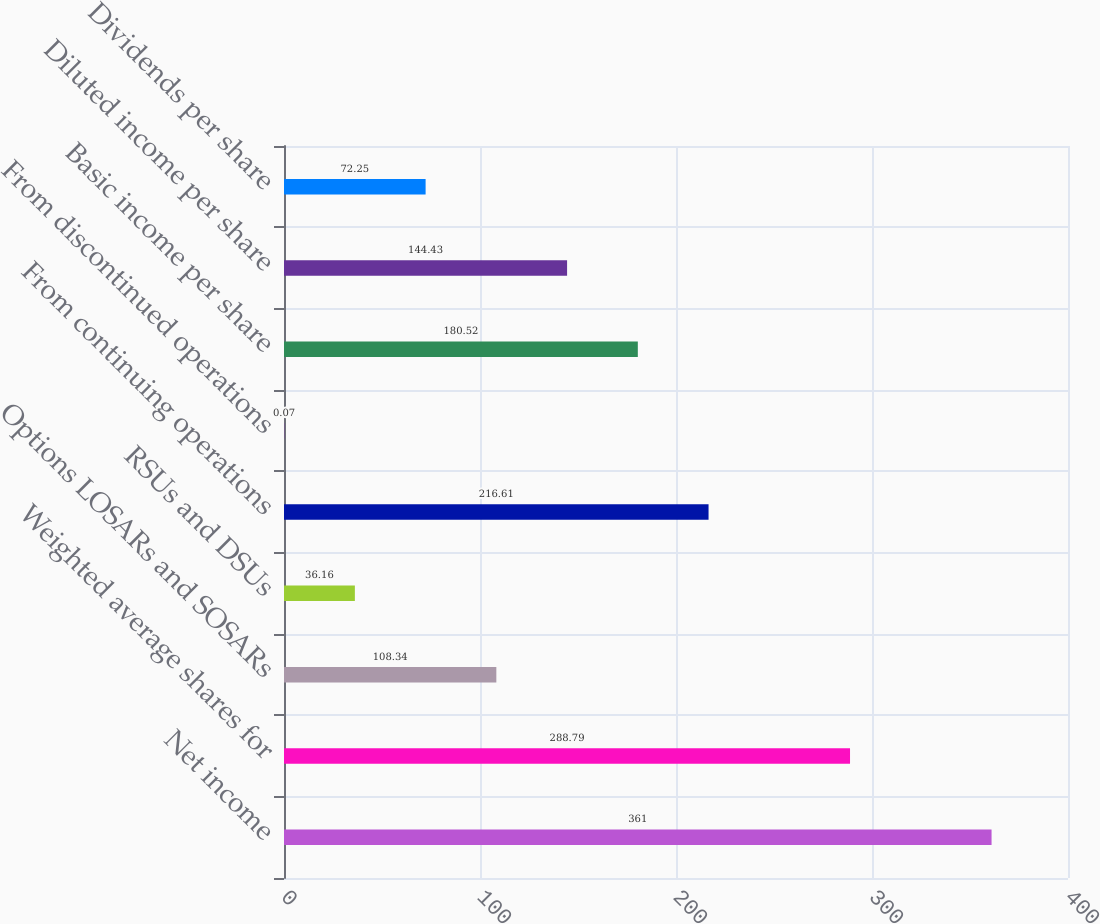Convert chart. <chart><loc_0><loc_0><loc_500><loc_500><bar_chart><fcel>Net income<fcel>Weighted average shares for<fcel>Options LOSARs and SOSARs<fcel>RSUs and DSUs<fcel>From continuing operations<fcel>From discontinued operations<fcel>Basic income per share<fcel>Diluted income per share<fcel>Dividends per share<nl><fcel>361<fcel>288.79<fcel>108.34<fcel>36.16<fcel>216.61<fcel>0.07<fcel>180.52<fcel>144.43<fcel>72.25<nl></chart> 